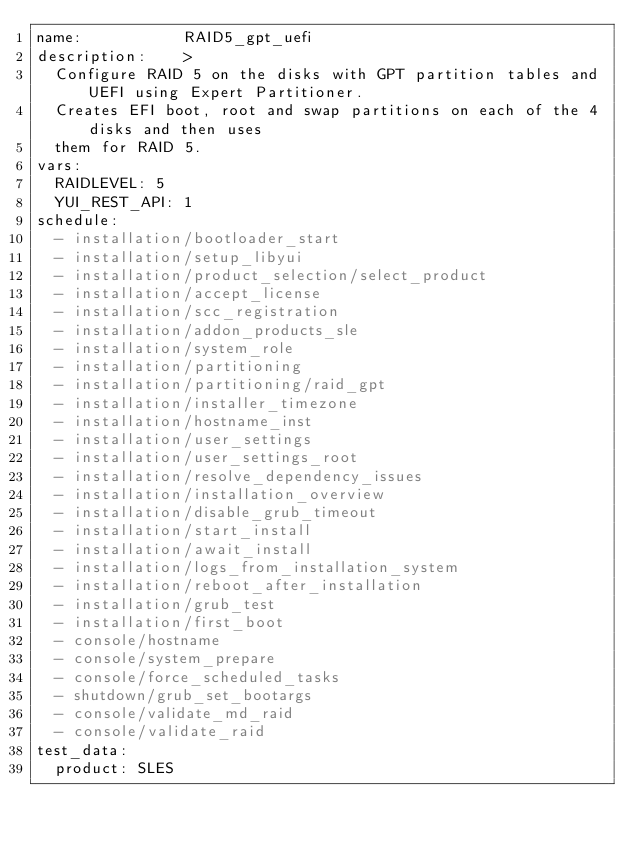<code> <loc_0><loc_0><loc_500><loc_500><_YAML_>name:           RAID5_gpt_uefi
description:    >
  Configure RAID 5 on the disks with GPT partition tables and UEFI using Expert Partitioner.
  Creates EFI boot, root and swap partitions on each of the 4 disks and then uses
  them for RAID 5.
vars:
  RAIDLEVEL: 5
  YUI_REST_API: 1
schedule:
  - installation/bootloader_start
  - installation/setup_libyui
  - installation/product_selection/select_product
  - installation/accept_license
  - installation/scc_registration
  - installation/addon_products_sle
  - installation/system_role
  - installation/partitioning
  - installation/partitioning/raid_gpt
  - installation/installer_timezone
  - installation/hostname_inst
  - installation/user_settings
  - installation/user_settings_root
  - installation/resolve_dependency_issues
  - installation/installation_overview
  - installation/disable_grub_timeout
  - installation/start_install
  - installation/await_install
  - installation/logs_from_installation_system
  - installation/reboot_after_installation
  - installation/grub_test
  - installation/first_boot
  - console/hostname
  - console/system_prepare
  - console/force_scheduled_tasks
  - shutdown/grub_set_bootargs
  - console/validate_md_raid
  - console/validate_raid
test_data:
  product: SLES</code> 